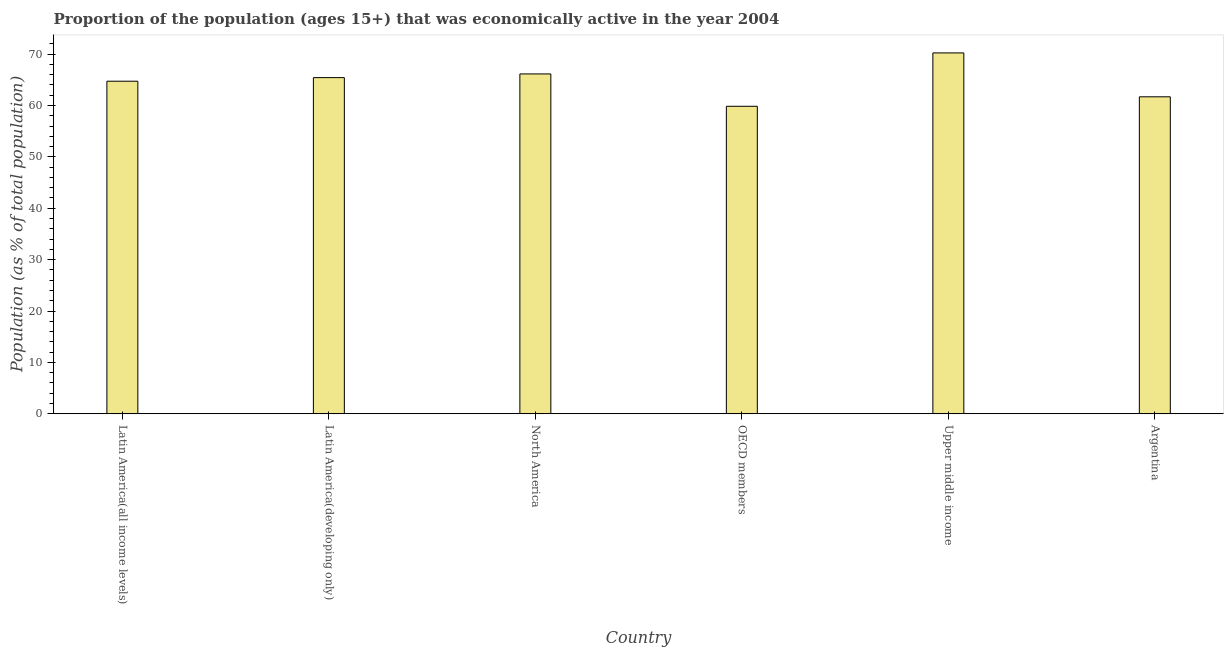Does the graph contain grids?
Keep it short and to the point. No. What is the title of the graph?
Offer a very short reply. Proportion of the population (ages 15+) that was economically active in the year 2004. What is the label or title of the X-axis?
Offer a terse response. Country. What is the label or title of the Y-axis?
Your answer should be very brief. Population (as % of total population). What is the percentage of economically active population in Latin America(developing only)?
Make the answer very short. 65.43. Across all countries, what is the maximum percentage of economically active population?
Your answer should be compact. 70.24. Across all countries, what is the minimum percentage of economically active population?
Make the answer very short. 59.85. In which country was the percentage of economically active population maximum?
Your response must be concise. Upper middle income. In which country was the percentage of economically active population minimum?
Provide a short and direct response. OECD members. What is the sum of the percentage of economically active population?
Give a very brief answer. 388.12. What is the difference between the percentage of economically active population in Argentina and OECD members?
Your answer should be compact. 1.85. What is the average percentage of economically active population per country?
Make the answer very short. 64.69. What is the median percentage of economically active population?
Provide a short and direct response. 65.09. In how many countries, is the percentage of economically active population greater than 40 %?
Ensure brevity in your answer.  6. What is the ratio of the percentage of economically active population in Latin America(all income levels) to that in OECD members?
Provide a short and direct response. 1.08. Is the percentage of economically active population in Argentina less than that in Latin America(developing only)?
Your answer should be very brief. Yes. What is the difference between the highest and the second highest percentage of economically active population?
Make the answer very short. 4.09. Is the sum of the percentage of economically active population in Argentina and Upper middle income greater than the maximum percentage of economically active population across all countries?
Keep it short and to the point. Yes. What is the difference between the highest and the lowest percentage of economically active population?
Provide a succinct answer. 10.39. How many bars are there?
Keep it short and to the point. 6. How many countries are there in the graph?
Ensure brevity in your answer.  6. What is the difference between two consecutive major ticks on the Y-axis?
Offer a very short reply. 10. Are the values on the major ticks of Y-axis written in scientific E-notation?
Provide a short and direct response. No. What is the Population (as % of total population) of Latin America(all income levels)?
Provide a succinct answer. 64.74. What is the Population (as % of total population) of Latin America(developing only)?
Make the answer very short. 65.43. What is the Population (as % of total population) of North America?
Provide a succinct answer. 66.15. What is the Population (as % of total population) of OECD members?
Give a very brief answer. 59.85. What is the Population (as % of total population) in Upper middle income?
Give a very brief answer. 70.24. What is the Population (as % of total population) in Argentina?
Ensure brevity in your answer.  61.7. What is the difference between the Population (as % of total population) in Latin America(all income levels) and Latin America(developing only)?
Provide a short and direct response. -0.7. What is the difference between the Population (as % of total population) in Latin America(all income levels) and North America?
Provide a succinct answer. -1.42. What is the difference between the Population (as % of total population) in Latin America(all income levels) and OECD members?
Ensure brevity in your answer.  4.88. What is the difference between the Population (as % of total population) in Latin America(all income levels) and Upper middle income?
Give a very brief answer. -5.51. What is the difference between the Population (as % of total population) in Latin America(all income levels) and Argentina?
Your answer should be compact. 3.04. What is the difference between the Population (as % of total population) in Latin America(developing only) and North America?
Your answer should be very brief. -0.72. What is the difference between the Population (as % of total population) in Latin America(developing only) and OECD members?
Provide a short and direct response. 5.58. What is the difference between the Population (as % of total population) in Latin America(developing only) and Upper middle income?
Your response must be concise. -4.81. What is the difference between the Population (as % of total population) in Latin America(developing only) and Argentina?
Ensure brevity in your answer.  3.73. What is the difference between the Population (as % of total population) in North America and OECD members?
Your answer should be very brief. 6.3. What is the difference between the Population (as % of total population) in North America and Upper middle income?
Your answer should be very brief. -4.09. What is the difference between the Population (as % of total population) in North America and Argentina?
Give a very brief answer. 4.45. What is the difference between the Population (as % of total population) in OECD members and Upper middle income?
Give a very brief answer. -10.39. What is the difference between the Population (as % of total population) in OECD members and Argentina?
Provide a short and direct response. -1.85. What is the difference between the Population (as % of total population) in Upper middle income and Argentina?
Offer a very short reply. 8.54. What is the ratio of the Population (as % of total population) in Latin America(all income levels) to that in OECD members?
Offer a terse response. 1.08. What is the ratio of the Population (as % of total population) in Latin America(all income levels) to that in Upper middle income?
Offer a very short reply. 0.92. What is the ratio of the Population (as % of total population) in Latin America(all income levels) to that in Argentina?
Ensure brevity in your answer.  1.05. What is the ratio of the Population (as % of total population) in Latin America(developing only) to that in North America?
Your response must be concise. 0.99. What is the ratio of the Population (as % of total population) in Latin America(developing only) to that in OECD members?
Give a very brief answer. 1.09. What is the ratio of the Population (as % of total population) in Latin America(developing only) to that in Upper middle income?
Keep it short and to the point. 0.93. What is the ratio of the Population (as % of total population) in Latin America(developing only) to that in Argentina?
Make the answer very short. 1.06. What is the ratio of the Population (as % of total population) in North America to that in OECD members?
Offer a very short reply. 1.1. What is the ratio of the Population (as % of total population) in North America to that in Upper middle income?
Keep it short and to the point. 0.94. What is the ratio of the Population (as % of total population) in North America to that in Argentina?
Ensure brevity in your answer.  1.07. What is the ratio of the Population (as % of total population) in OECD members to that in Upper middle income?
Offer a terse response. 0.85. What is the ratio of the Population (as % of total population) in Upper middle income to that in Argentina?
Ensure brevity in your answer.  1.14. 